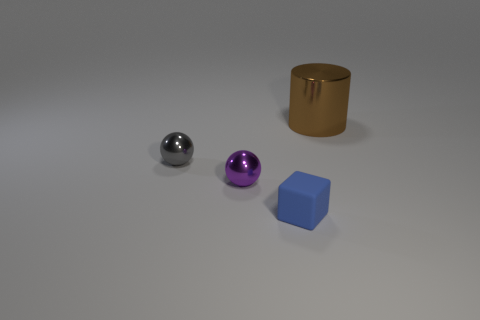Add 4 small red metal objects. How many objects exist? 8 Subtract all blocks. How many objects are left? 3 Add 1 small objects. How many small objects exist? 4 Subtract 0 cyan cylinders. How many objects are left? 4 Subtract 1 cylinders. How many cylinders are left? 0 Subtract all purple balls. Subtract all yellow cubes. How many balls are left? 1 Subtract all green cylinders. How many purple balls are left? 1 Subtract all metal things. Subtract all big brown metal cylinders. How many objects are left? 0 Add 3 small rubber objects. How many small rubber objects are left? 4 